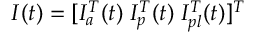Convert formula to latex. <formula><loc_0><loc_0><loc_500><loc_500>I ( t ) = [ I _ { a } ^ { T } ( t ) \, I _ { p } ^ { T } ( t ) \, I _ { p l } ^ { T } ( t ) ] ^ { T }</formula> 